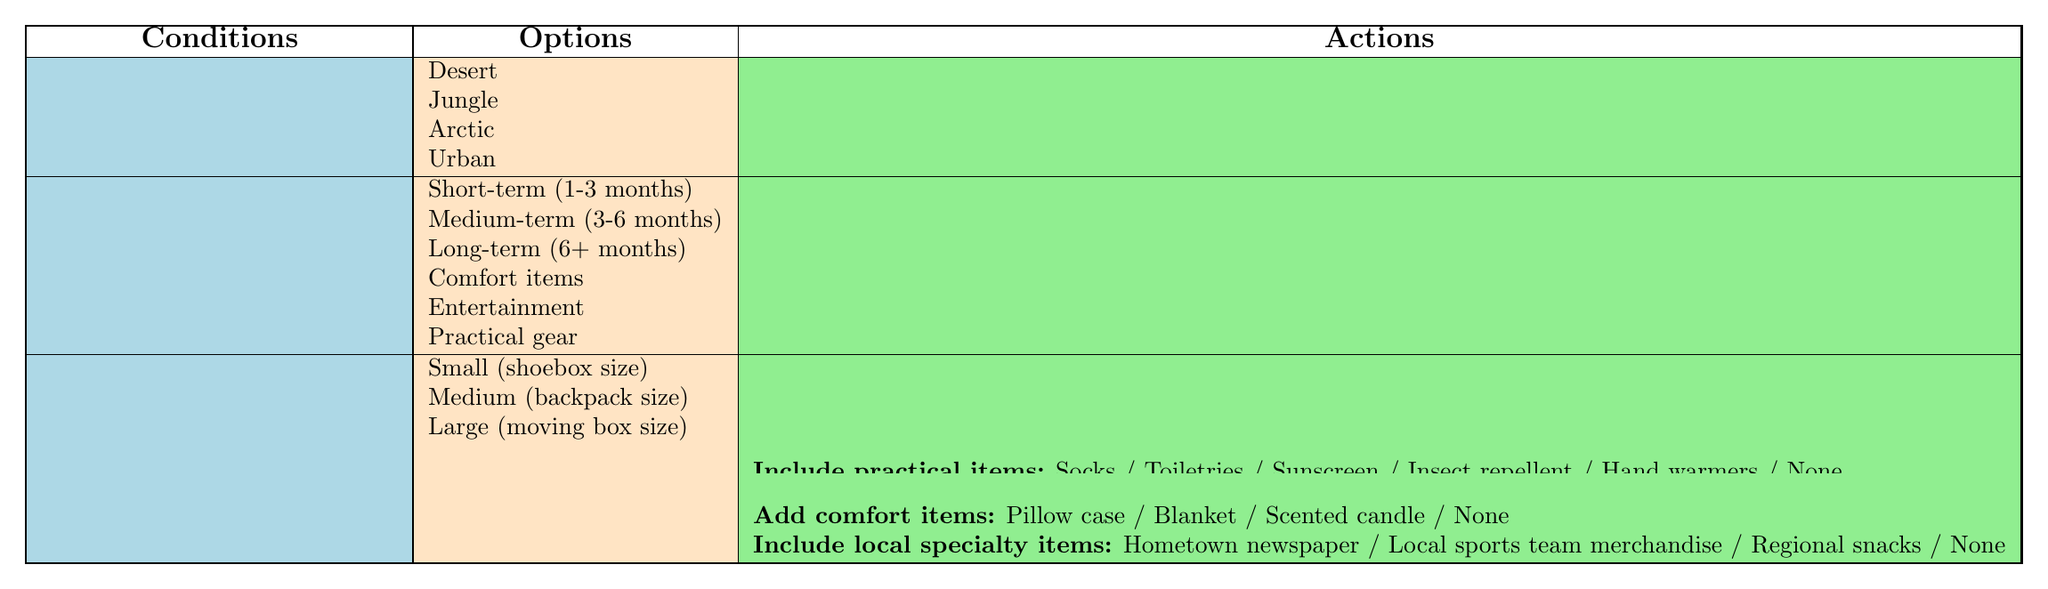What are the options for the soldier's personal preference? The table indicates that the options for the soldier's personal preference are "Comfort items," "Entertainment," and "Practical gear."
Answer: Comfort items, Entertainment, Practical gear Can a care package include personal letters and photos for soldiers in an Urban deployment location? Yes, the table includes the option to "Include personal letters and photos" for all deployment locations, including Urban.
Answer: Yes Which non-perishable snack option is offered for a medium-term deployment? The table suggests that for a medium-term deployment, the snack options are "Trail mix," "Beef jerky," "Energy bars," "Candy," or "None," hence all options apply.
Answer: Trail mix, Beef jerky, Energy bars, Candy, None If a soldier prefers practical gear and has a large space for the package, what items can be added? For a soldier who prefers practical gear and has a large package space, the options for practical items include "Socks," "Toiletries," "Sunscreen," "Insect repellent," "Hand warmers," or "None."
Answer: Socks, Toiletries, Sunscreen, Insect repellent, Hand warmers, None Is it true that soldiers in Jungle locations can receive comfort items in their packages? Yes, the table shows that "Comfort items" can be added to packages regardless of the deployment location including Jungle.
Answer: Yes How many total options are there for adding entertainment items if a soldier has small package space? For small package space, there are four options available for adding entertainment items: "Books," "Playing cards," "Portable game console," and "None." Therefore, the total is 4 options.
Answer: 4 What combinations of conditions usually lead to including local specialty items? Local specialty items can be included in packages for any deployment location, deployment duration, and preference, meaning there are no restrictions based on conditions.
Answer: All combinations If a soldier is deployed in the Arctic for more than 6 months and their preference is entertainment, what items can be included in their care package? For a soldier in the Arctic with a long-term deployment and a preference for entertainment, options to include are "Books," "Playing cards," "Portable game console," or "None," so all entertainment items can be included.
Answer: Books, Playing cards, Portable game console, None Which deployment location has the highest number of care package action options? All deployment locations have the same set of action options available, so there is no single location with the highest number of options.
Answer: Equal across all locations 